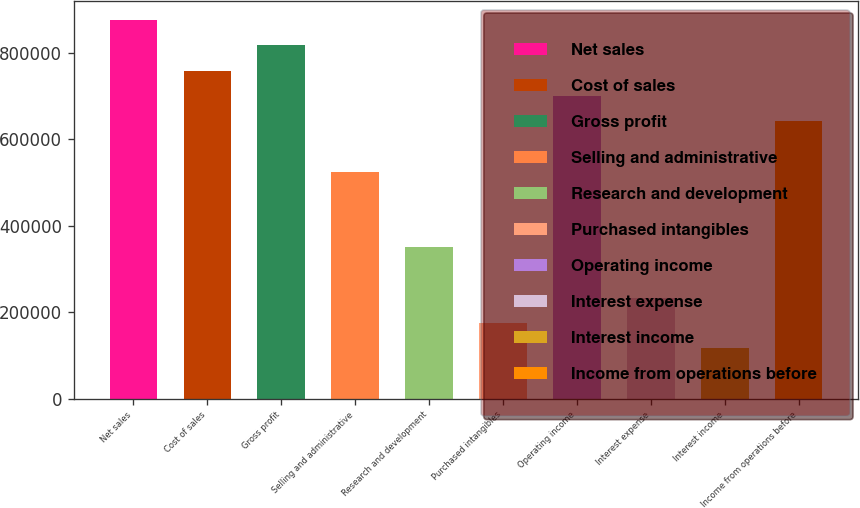<chart> <loc_0><loc_0><loc_500><loc_500><bar_chart><fcel>Net sales<fcel>Cost of sales<fcel>Gross profit<fcel>Selling and administrative<fcel>Research and development<fcel>Purchased intangibles<fcel>Operating income<fcel>Interest expense<fcel>Interest income<fcel>Income from operations before<nl><fcel>875804<fcel>759030<fcel>817417<fcel>525483<fcel>350323<fcel>175162<fcel>700644<fcel>233549<fcel>116775<fcel>642257<nl></chart> 